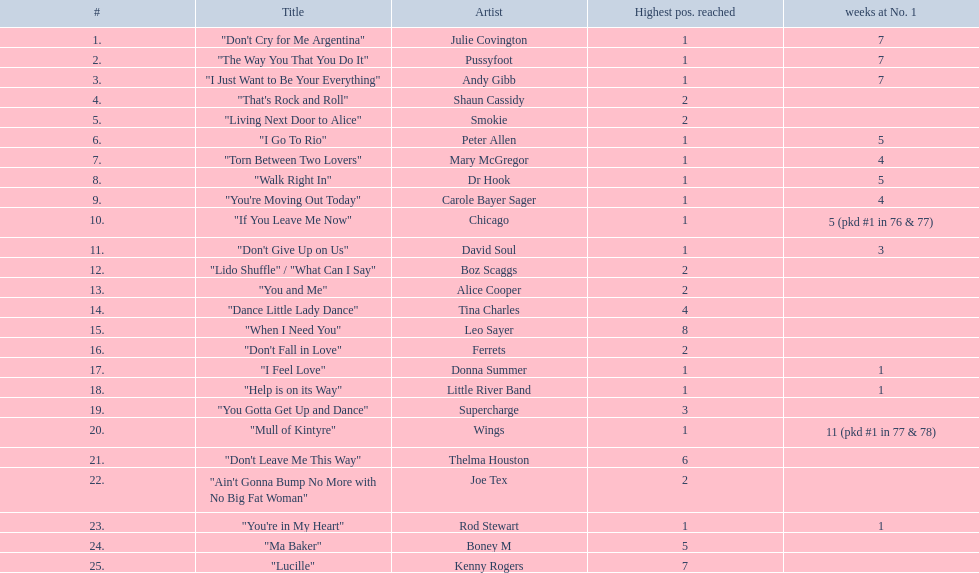What is the longest period a song has been at the number 1 spot? 11 (pkd #1 in 77 & 78). Which melody had an 11-week stay at the top? "Mull of Kintyre". Which ensemble had a number 1 success with this composition? Wings. 